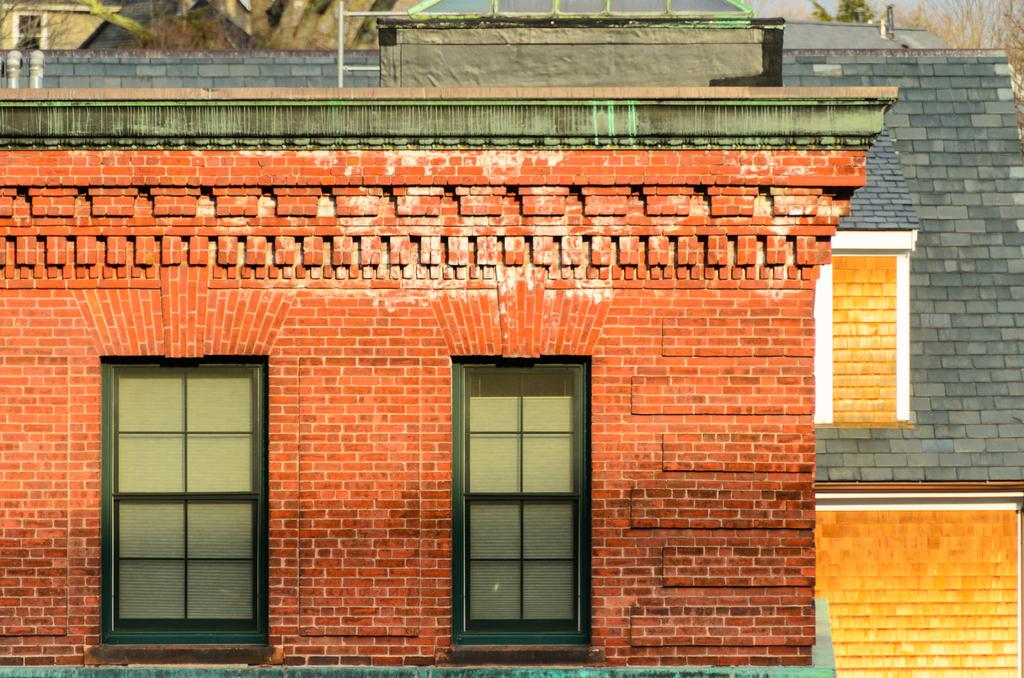What type of structures can be seen in the image? There are buildings with windows in the image. What is the purpose of the large cylindrical object in the image? There is a water tank in the image. What type of natural elements are present in the image? Trees are visible in the image. Is the existence of a jail confirmed in the image? There is no mention or indication of a jail in the image. What type of bag is hanging from the water tank in the image? There is no bag present in the image; it only features buildings, a water tank, and trees. 